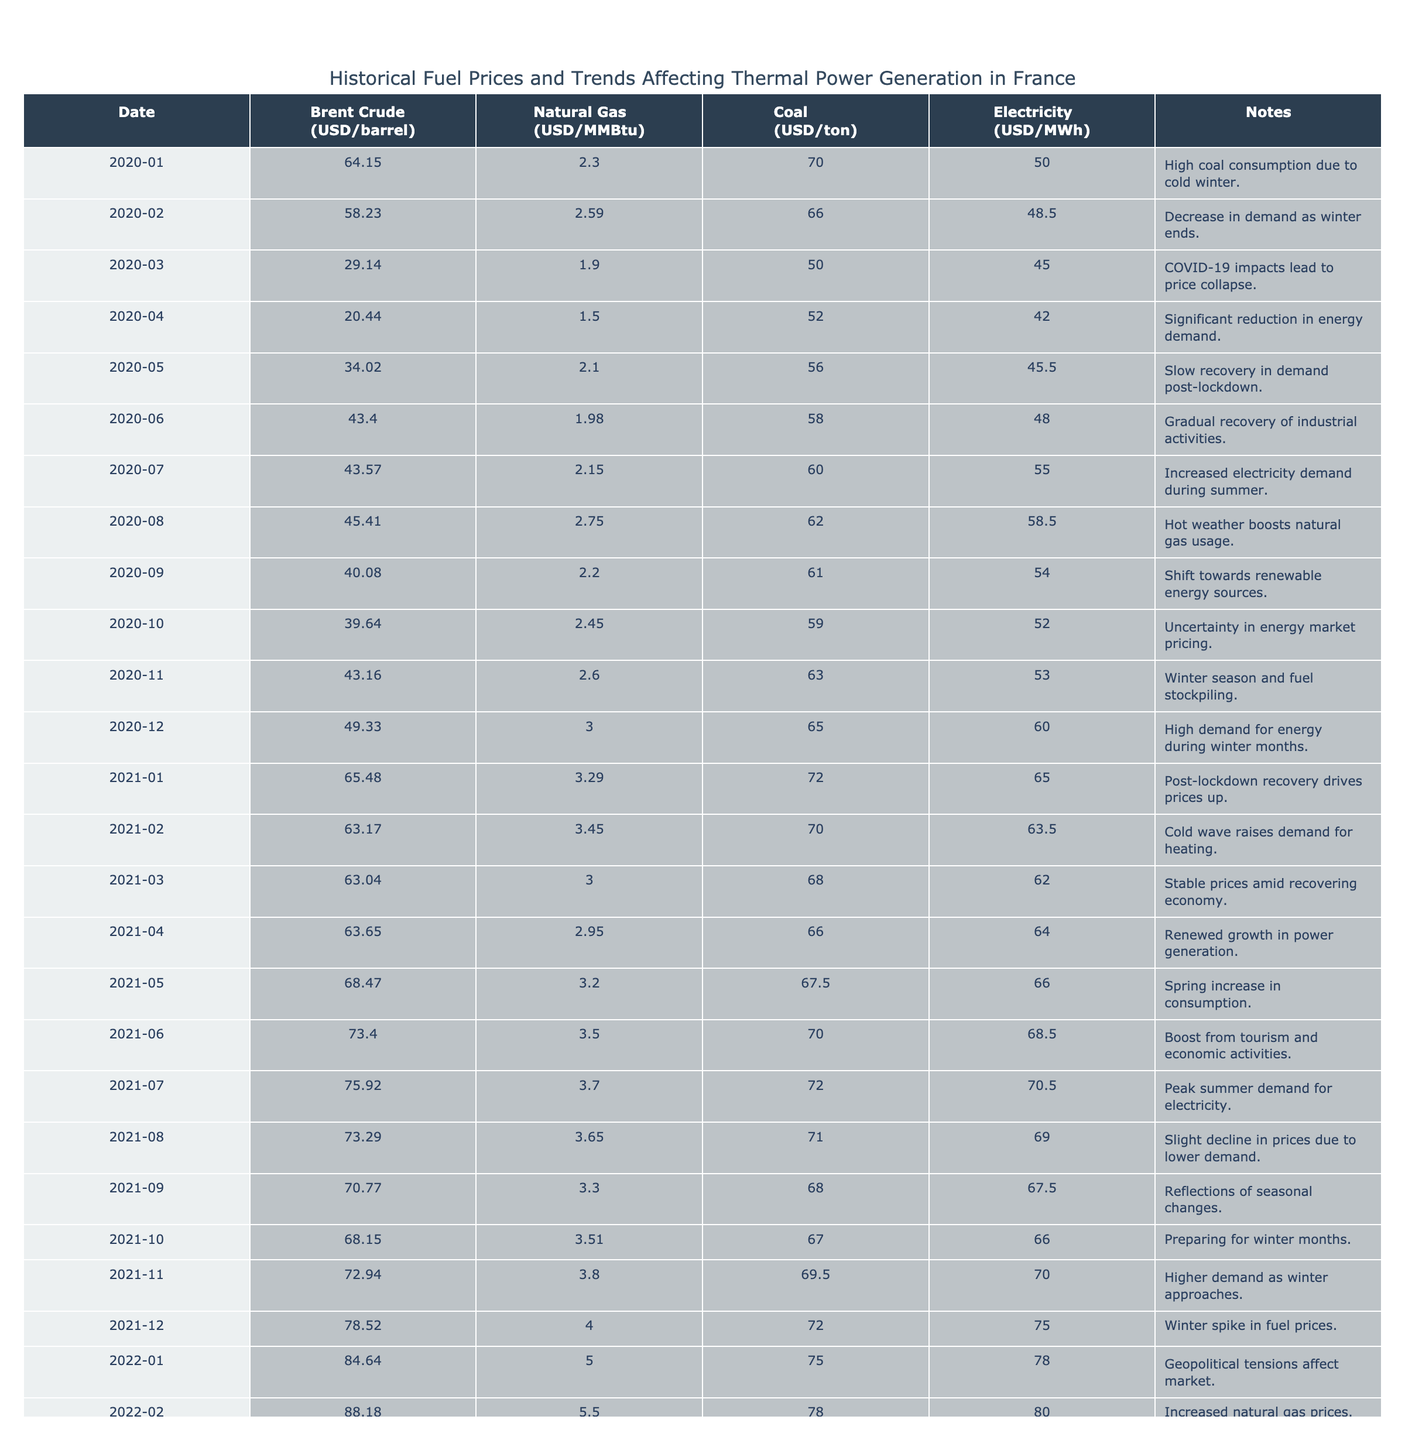What was the highest Brent Crude Price recorded in 2022? The highest Brent Crude Price in 2022 is found in December, listed as 100.00 USD/barrel.
Answer: 100.00 USD/barrel Which month in 2021 had the lowest coal price and what was it? In 2021, the lowest coal price occurred in October, where it was 67.00 USD/ton.
Answer: 67.00 USD/ton How did the natural gas price change from January 2020 to December 2022? The natural gas price was 2.30 USD/MMBtu in January 2020 and rose to 7.00 USD/MMBtu by December 2022. This indicates an increase of 4.70 USD/MMBtu over the period.
Answer: It increased by 4.70 USD/MMBtu Was there a month in 2020 where all fuel prices decreased compared to the previous month? Yes, in March 2020, all fuel prices dropped compared to February 2020. Brent crude fell from 58.23 to 29.14, natural gas from 2.59 to 1.90, and coal from 66.00 to 50.00.
Answer: Yes What was the average electricity price during the winter months (December to February) of 2021? The electricity prices in winter 2021 are: December 2021 (75.00), January 2021 (65.00), and February 2021 (63.50). The average is calculated as (75.00 + 65.00 + 63.50) / 3 = 67.83.
Answer: 67.83 USD/MWh 